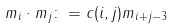<formula> <loc_0><loc_0><loc_500><loc_500>m _ { i } \cdot m _ { j } \colon = c ( i , j ) m _ { i + j - 3 }</formula> 